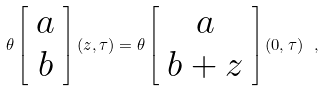Convert formula to latex. <formula><loc_0><loc_0><loc_500><loc_500>\theta \left [ \begin{array} { c } a \\ b \end{array} \right ] ( z , \tau ) = \theta \left [ \begin{array} { c } a \\ b + z \end{array} \right ] ( 0 , \tau ) \ ,</formula> 